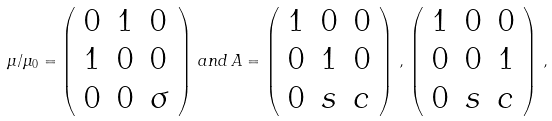Convert formula to latex. <formula><loc_0><loc_0><loc_500><loc_500>\mu / \mu _ { 0 } = \left ( \begin{array} { l l l } { 0 } & { 1 } & { 0 } \\ { 1 } & { 0 } & { 0 } \\ { 0 } & { 0 } & { \sigma } \end{array} \right ) \, a n d \, A = \left ( \begin{array} { l l l } { 1 } & { 0 } & { 0 } \\ { 0 } & { 1 } & { 0 } \\ { 0 } & { s } & { c } \end{array} \right ) \, , \, \left ( \begin{array} { l l l } { 1 } & { 0 } & { 0 } \\ { 0 } & { 0 } & { 1 } \\ { 0 } & { s } & { c } \end{array} \right ) \, ,</formula> 